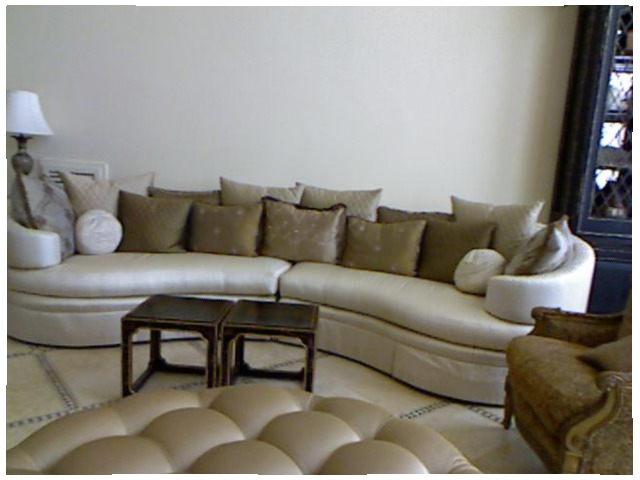<image>
Is there a table in front of the sofa? Yes. The table is positioned in front of the sofa, appearing closer to the camera viewpoint. Is the cabinet behind the couch? Yes. From this viewpoint, the cabinet is positioned behind the couch, with the couch partially or fully occluding the cabinet. 